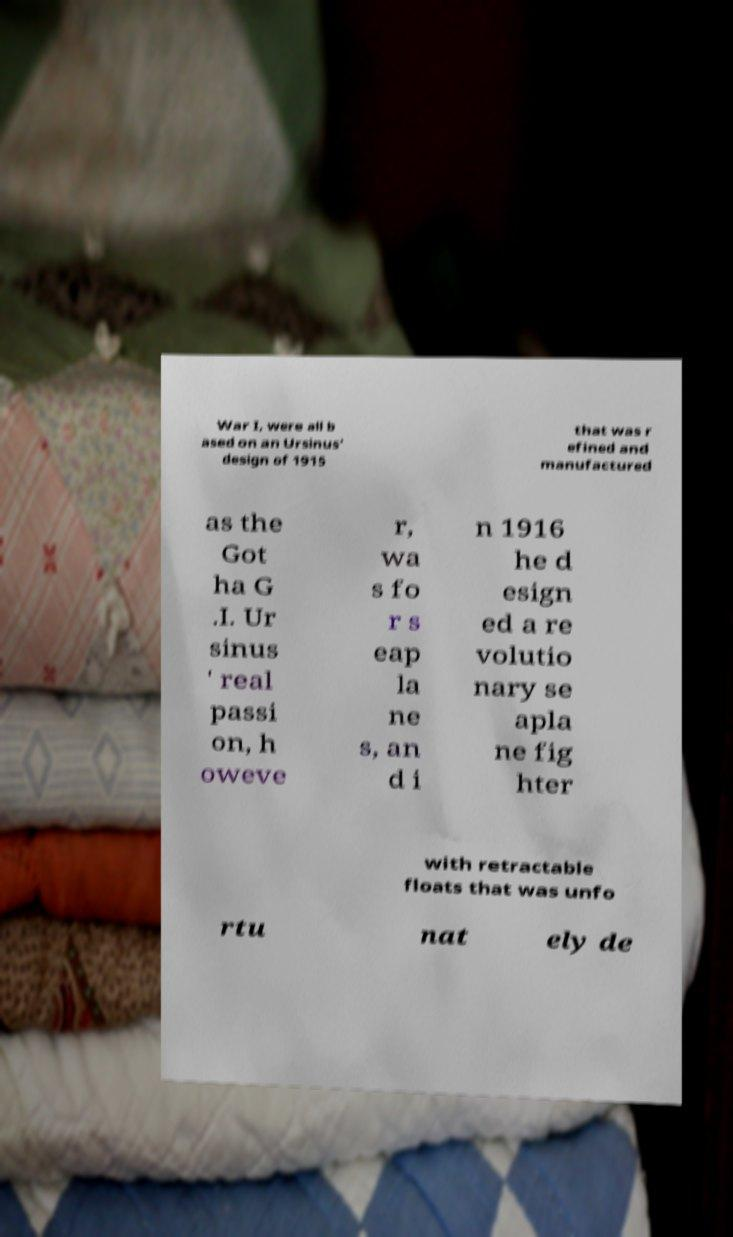Please read and relay the text visible in this image. What does it say? War I, were all b ased on an Ursinus' design of 1915 that was r efined and manufactured as the Got ha G .I. Ur sinus ' real passi on, h oweve r, wa s fo r s eap la ne s, an d i n 1916 he d esign ed a re volutio nary se apla ne fig hter with retractable floats that was unfo rtu nat ely de 